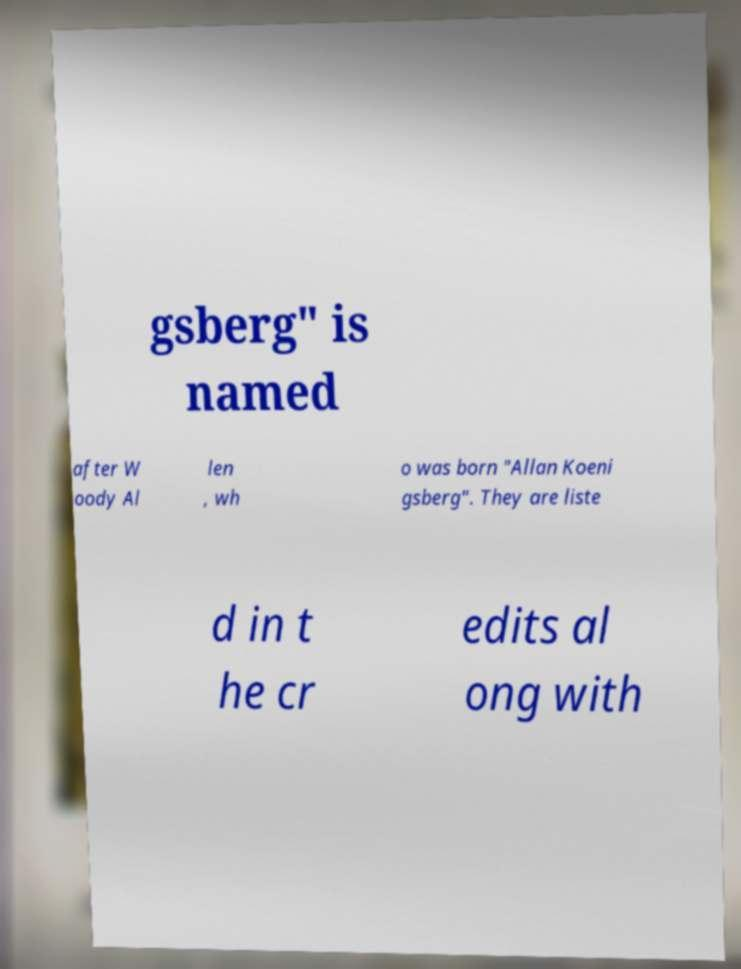Please identify and transcribe the text found in this image. gsberg" is named after W oody Al len , wh o was born "Allan Koeni gsberg". They are liste d in t he cr edits al ong with 